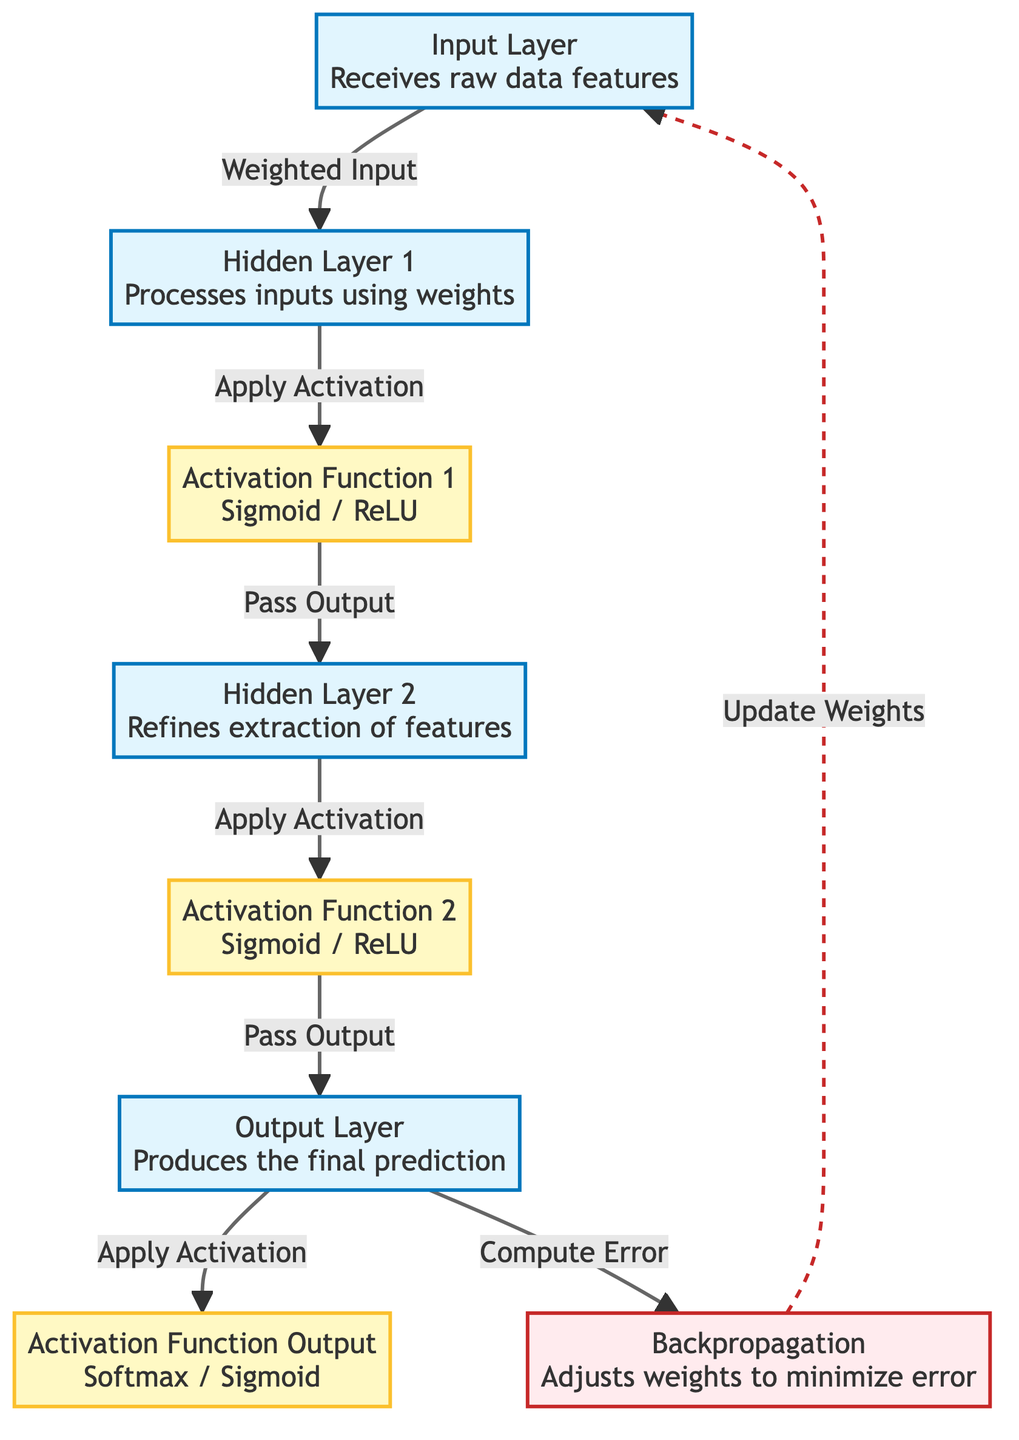What is the first layer in the neural network? The first layer in the diagram is labeled "Input Layer," which receives the raw data features.
Answer: Input Layer How many hidden layers are present in the network? There are two hidden layers shown in the diagram: Hidden Layer 1 and Hidden Layer 2.
Answer: 2 What activation function is applied after Hidden Layer 1? The activation function applied after Hidden Layer 1 is labeled "Activation Function 1," which can be either Sigmoid or ReLU.
Answer: Activation Function 1 What is the role of the Backpropagation node? The Backpropagation node adjusts the weights in the network to minimize the error after computation.
Answer: Adjusts weights Which layer produces the final prediction? The layer that produces the final prediction is the "Output Layer."
Answer: Output Layer What does the Output Layer use to compute the error? The Output Layer computes the error through the Backpropagation process as indicated by the directed edge labeled "Compute Error."
Answer: Backpropagation How does the data flow from the Input Layer to the Output Layer? The diagram shows a directed flow from the Input Layer to Hidden Layer 1, then to Activation Function 1, Hidden Layer 2, Activation Function 2, and finally to the Output Layer.
Answer: Sequential flow What type of activation function is used in the Output Layer? The Output Layer uses "Activation Function Output," which can be either Softmax or Sigmoid as stated in the diagram.
Answer: Softmax / Sigmoid What style is used for the links representing backpropagation? The links representing backpropagation are styled with a dashed line, indicating the flow is not direct but corrective.
Answer: Dashed line 